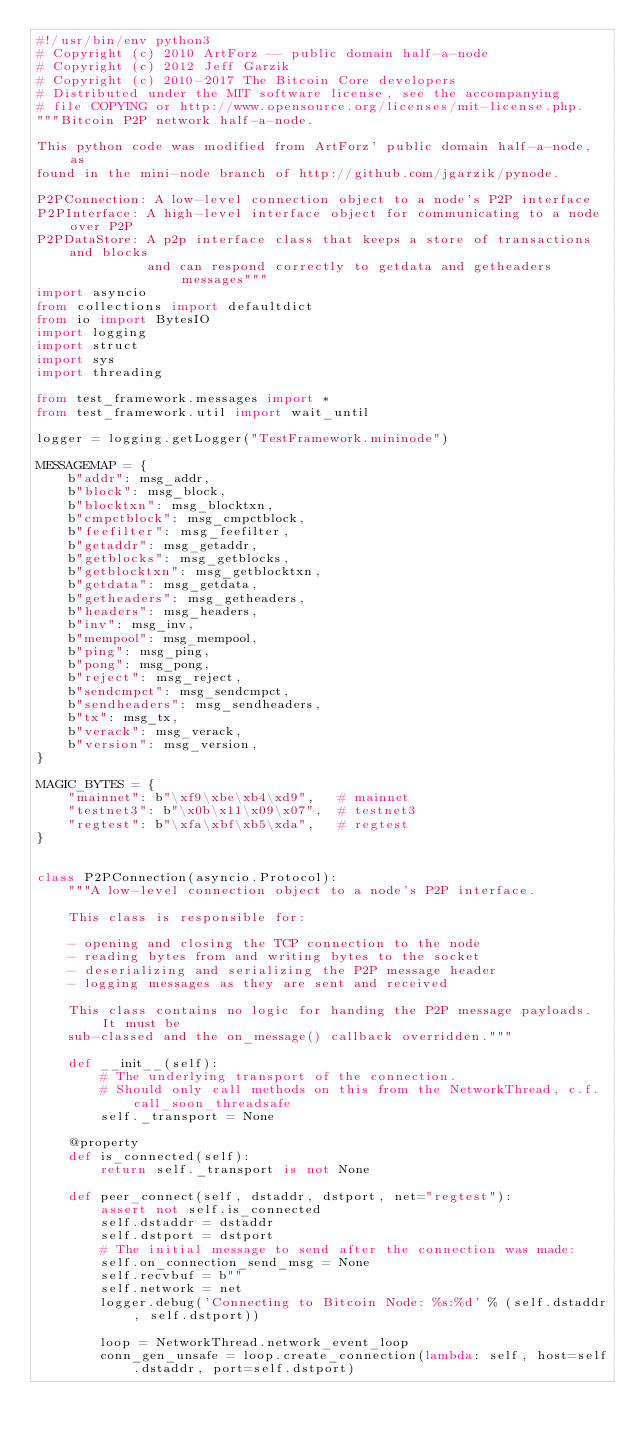<code> <loc_0><loc_0><loc_500><loc_500><_Python_>#!/usr/bin/env python3
# Copyright (c) 2010 ArtForz -- public domain half-a-node
# Copyright (c) 2012 Jeff Garzik
# Copyright (c) 2010-2017 The Bitcoin Core developers
# Distributed under the MIT software license, see the accompanying
# file COPYING or http://www.opensource.org/licenses/mit-license.php.
"""Bitcoin P2P network half-a-node.

This python code was modified from ArtForz' public domain half-a-node, as
found in the mini-node branch of http://github.com/jgarzik/pynode.

P2PConnection: A low-level connection object to a node's P2P interface
P2PInterface: A high-level interface object for communicating to a node over P2P
P2PDataStore: A p2p interface class that keeps a store of transactions and blocks
              and can respond correctly to getdata and getheaders messages"""
import asyncio
from collections import defaultdict
from io import BytesIO
import logging
import struct
import sys
import threading

from test_framework.messages import *
from test_framework.util import wait_until

logger = logging.getLogger("TestFramework.mininode")

MESSAGEMAP = {
    b"addr": msg_addr,
    b"block": msg_block,
    b"blocktxn": msg_blocktxn,
    b"cmpctblock": msg_cmpctblock,
    b"feefilter": msg_feefilter,
    b"getaddr": msg_getaddr,
    b"getblocks": msg_getblocks,
    b"getblocktxn": msg_getblocktxn,
    b"getdata": msg_getdata,
    b"getheaders": msg_getheaders,
    b"headers": msg_headers,
    b"inv": msg_inv,
    b"mempool": msg_mempool,
    b"ping": msg_ping,
    b"pong": msg_pong,
    b"reject": msg_reject,
    b"sendcmpct": msg_sendcmpct,
    b"sendheaders": msg_sendheaders,
    b"tx": msg_tx,
    b"verack": msg_verack,
    b"version": msg_version,
}

MAGIC_BYTES = {
    "mainnet": b"\xf9\xbe\xb4\xd9",   # mainnet
    "testnet3": b"\x0b\x11\x09\x07",  # testnet3
    "regtest": b"\xfa\xbf\xb5\xda",   # regtest
}


class P2PConnection(asyncio.Protocol):
    """A low-level connection object to a node's P2P interface.

    This class is responsible for:

    - opening and closing the TCP connection to the node
    - reading bytes from and writing bytes to the socket
    - deserializing and serializing the P2P message header
    - logging messages as they are sent and received

    This class contains no logic for handing the P2P message payloads. It must be
    sub-classed and the on_message() callback overridden."""

    def __init__(self):
        # The underlying transport of the connection.
        # Should only call methods on this from the NetworkThread, c.f. call_soon_threadsafe
        self._transport = None

    @property
    def is_connected(self):
        return self._transport is not None

    def peer_connect(self, dstaddr, dstport, net="regtest"):
        assert not self.is_connected
        self.dstaddr = dstaddr
        self.dstport = dstport
        # The initial message to send after the connection was made:
        self.on_connection_send_msg = None
        self.recvbuf = b""
        self.network = net
        logger.debug('Connecting to Bitcoin Node: %s:%d' % (self.dstaddr, self.dstport))

        loop = NetworkThread.network_event_loop
        conn_gen_unsafe = loop.create_connection(lambda: self, host=self.dstaddr, port=self.dstport)</code> 